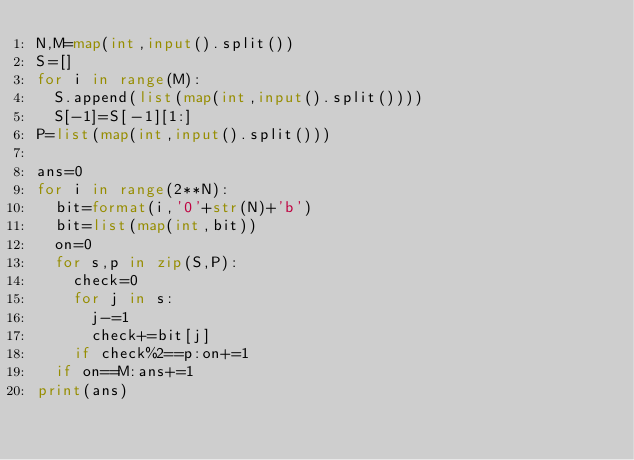<code> <loc_0><loc_0><loc_500><loc_500><_Python_>N,M=map(int,input().split())
S=[]
for i in range(M):
  S.append(list(map(int,input().split())))
  S[-1]=S[-1][1:]
P=list(map(int,input().split()))

ans=0
for i in range(2**N):
  bit=format(i,'0'+str(N)+'b')
  bit=list(map(int,bit))
  on=0
  for s,p in zip(S,P):
    check=0
    for j in s:
      j-=1
      check+=bit[j]
    if check%2==p:on+=1
  if on==M:ans+=1  
print(ans)</code> 